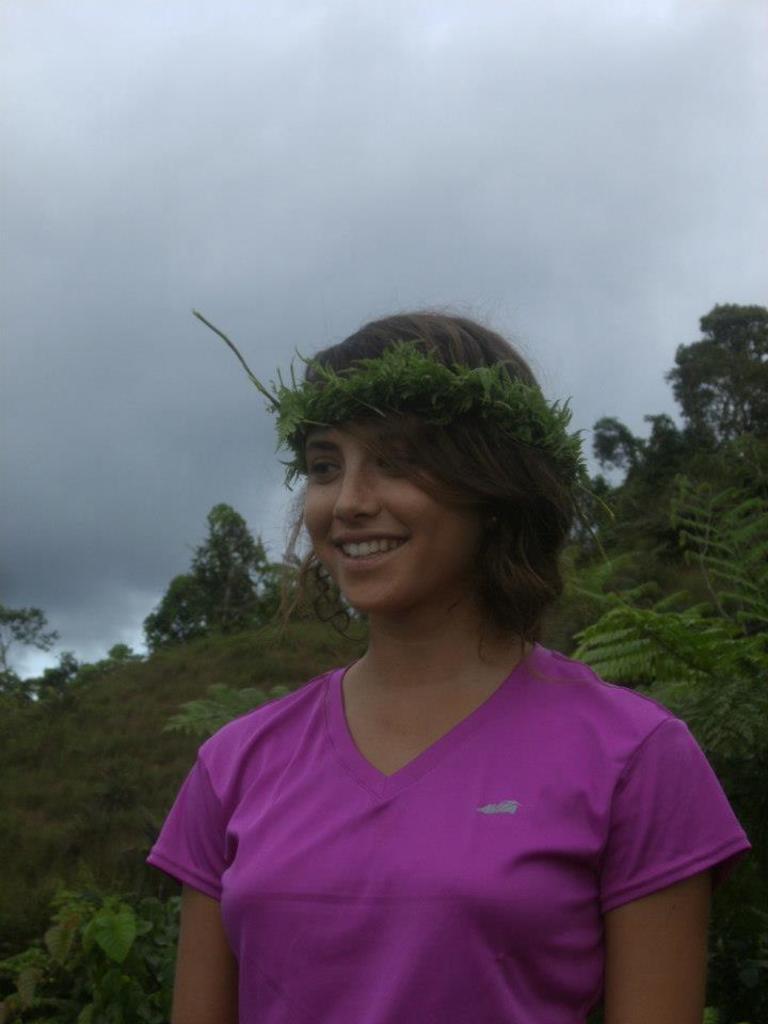Can you describe this image briefly? In the center of the image there is a woman. In the background we can see trees, sky and clouds. 